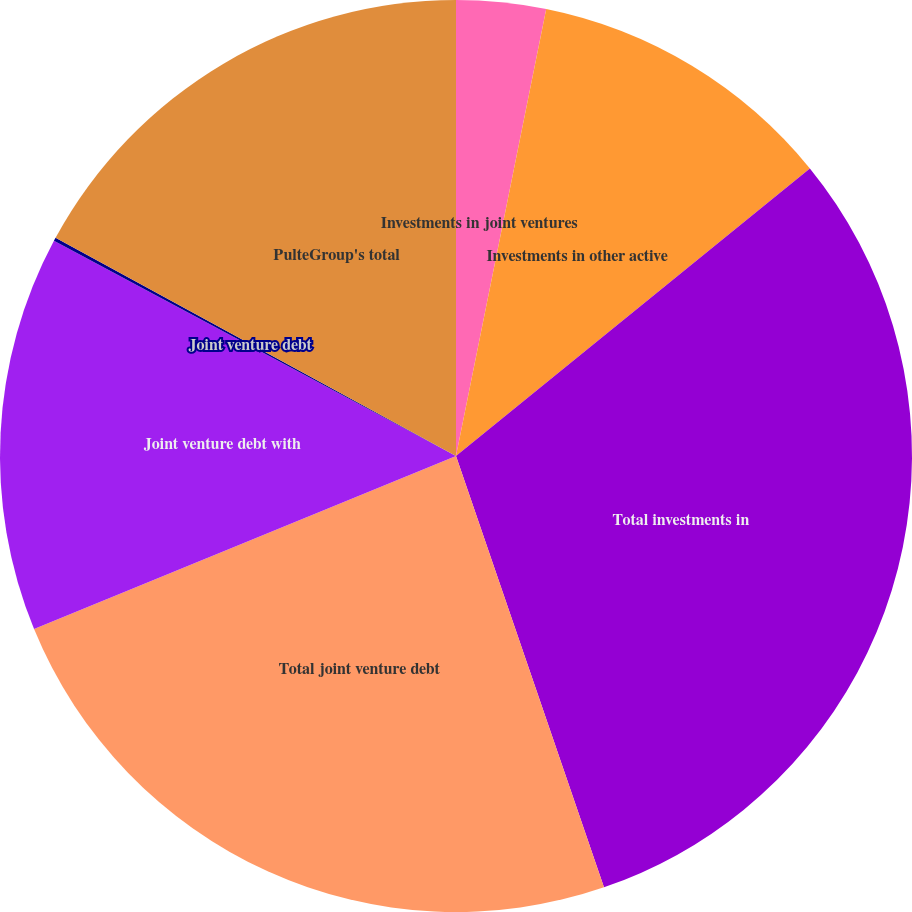<chart> <loc_0><loc_0><loc_500><loc_500><pie_chart><fcel>Investments in joint ventures<fcel>Investments in other active<fcel>Total investments in<fcel>Total joint venture debt<fcel>Joint venture debt with<fcel>Joint venture debt<fcel>PulteGroup's total<nl><fcel>3.17%<fcel>10.97%<fcel>30.6%<fcel>24.07%<fcel>14.01%<fcel>0.12%<fcel>17.06%<nl></chart> 